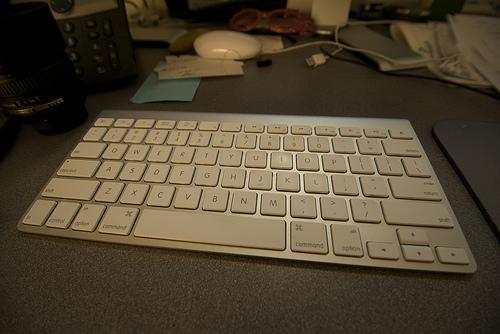Question: where was this picture taken?
Choices:
A. Zoo.
B. Mall.
C. Airport.
D. A desk.
Answer with the letter. Answer: D Question: who is in this picture?
Choices:
A. No one.
B. Billy Crystal.
C. John Goodman.
D. Tony Iomi.
Answer with the letter. Answer: A Question: where is the mouse located?
Choices:
A. On the desk.
B. Behind the keyboard.
C. In the box.
D. On the floor.
Answer with the letter. Answer: B 